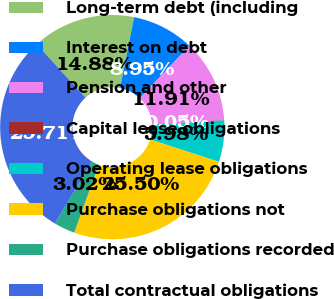Convert chart to OTSL. <chart><loc_0><loc_0><loc_500><loc_500><pie_chart><fcel>Long-term debt (including<fcel>Interest on debt<fcel>Pension and other<fcel>Capital lease obligations<fcel>Operating lease obligations<fcel>Purchase obligations not<fcel>Purchase obligations recorded<fcel>Total contractual obligations<nl><fcel>14.88%<fcel>8.95%<fcel>11.91%<fcel>0.05%<fcel>5.98%<fcel>25.5%<fcel>3.02%<fcel>29.71%<nl></chart> 